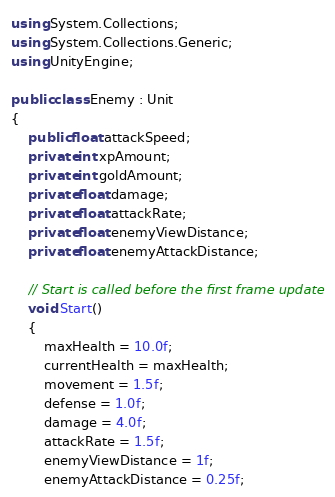Convert code to text. <code><loc_0><loc_0><loc_500><loc_500><_C#_>using System.Collections;
using System.Collections.Generic;
using UnityEngine;

public class Enemy : Unit
{
    public float attackSpeed;
    private int xpAmount;
    private int goldAmount;
    private float damage;
    private float attackRate;
    private float enemyViewDistance;
    private float enemyAttackDistance;

    // Start is called before the first frame update
    void Start()
    {
        maxHealth = 10.0f;
        currentHealth = maxHealth;
        movement = 1.5f;
        defense = 1.0f;
        damage = 4.0f;
        attackRate = 1.5f;
        enemyViewDistance = 1f;
        enemyAttackDistance = 0.25f;</code> 